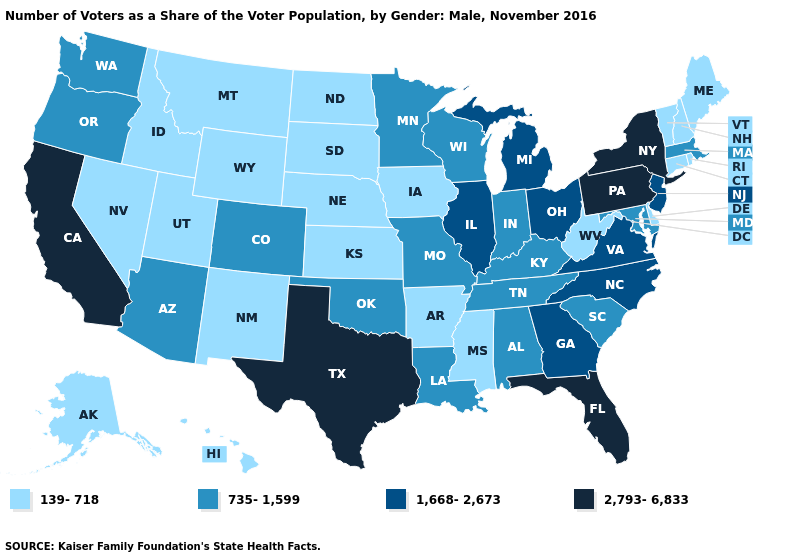Does Iowa have a lower value than Washington?
Give a very brief answer. Yes. What is the value of Arizona?
Write a very short answer. 735-1,599. Among the states that border Oklahoma , which have the highest value?
Concise answer only. Texas. How many symbols are there in the legend?
Quick response, please. 4. Does Kansas have the highest value in the MidWest?
Write a very short answer. No. What is the lowest value in states that border Delaware?
Write a very short answer. 735-1,599. Does New York have a higher value than New Hampshire?
Keep it brief. Yes. Among the states that border Indiana , does Michigan have the highest value?
Give a very brief answer. Yes. What is the lowest value in the South?
Be succinct. 139-718. Name the states that have a value in the range 139-718?
Be succinct. Alaska, Arkansas, Connecticut, Delaware, Hawaii, Idaho, Iowa, Kansas, Maine, Mississippi, Montana, Nebraska, Nevada, New Hampshire, New Mexico, North Dakota, Rhode Island, South Dakota, Utah, Vermont, West Virginia, Wyoming. Name the states that have a value in the range 139-718?
Write a very short answer. Alaska, Arkansas, Connecticut, Delaware, Hawaii, Idaho, Iowa, Kansas, Maine, Mississippi, Montana, Nebraska, Nevada, New Hampshire, New Mexico, North Dakota, Rhode Island, South Dakota, Utah, Vermont, West Virginia, Wyoming. What is the lowest value in states that border California?
Keep it brief. 139-718. Name the states that have a value in the range 2,793-6,833?
Be succinct. California, Florida, New York, Pennsylvania, Texas. Name the states that have a value in the range 735-1,599?
Short answer required. Alabama, Arizona, Colorado, Indiana, Kentucky, Louisiana, Maryland, Massachusetts, Minnesota, Missouri, Oklahoma, Oregon, South Carolina, Tennessee, Washington, Wisconsin. What is the lowest value in the Northeast?
Give a very brief answer. 139-718. 